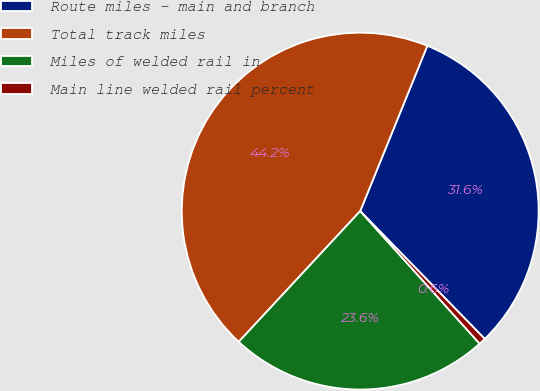Convert chart to OTSL. <chart><loc_0><loc_0><loc_500><loc_500><pie_chart><fcel>Route miles - main and branch<fcel>Total track miles<fcel>Miles of welded rail in<fcel>Main line welded rail percent<nl><fcel>31.57%<fcel>44.22%<fcel>23.59%<fcel>0.62%<nl></chart> 